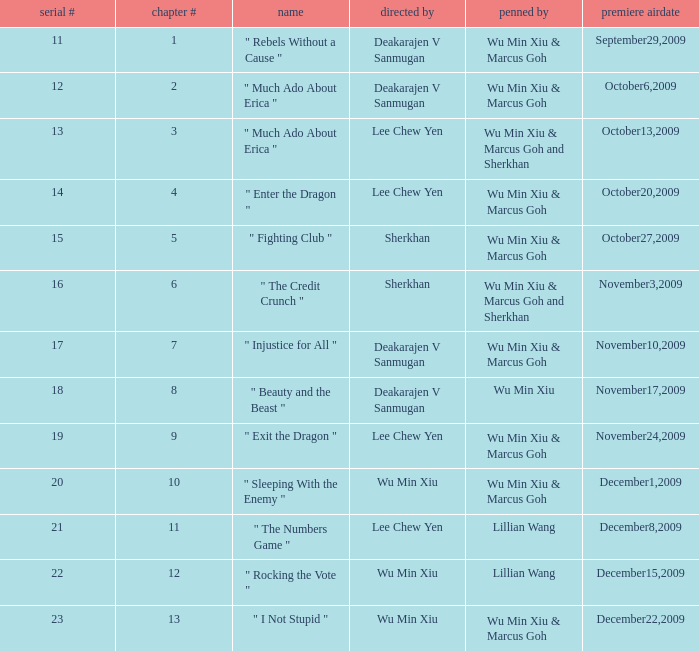What was the title for episode 2? " Much Ado About Erica ". 